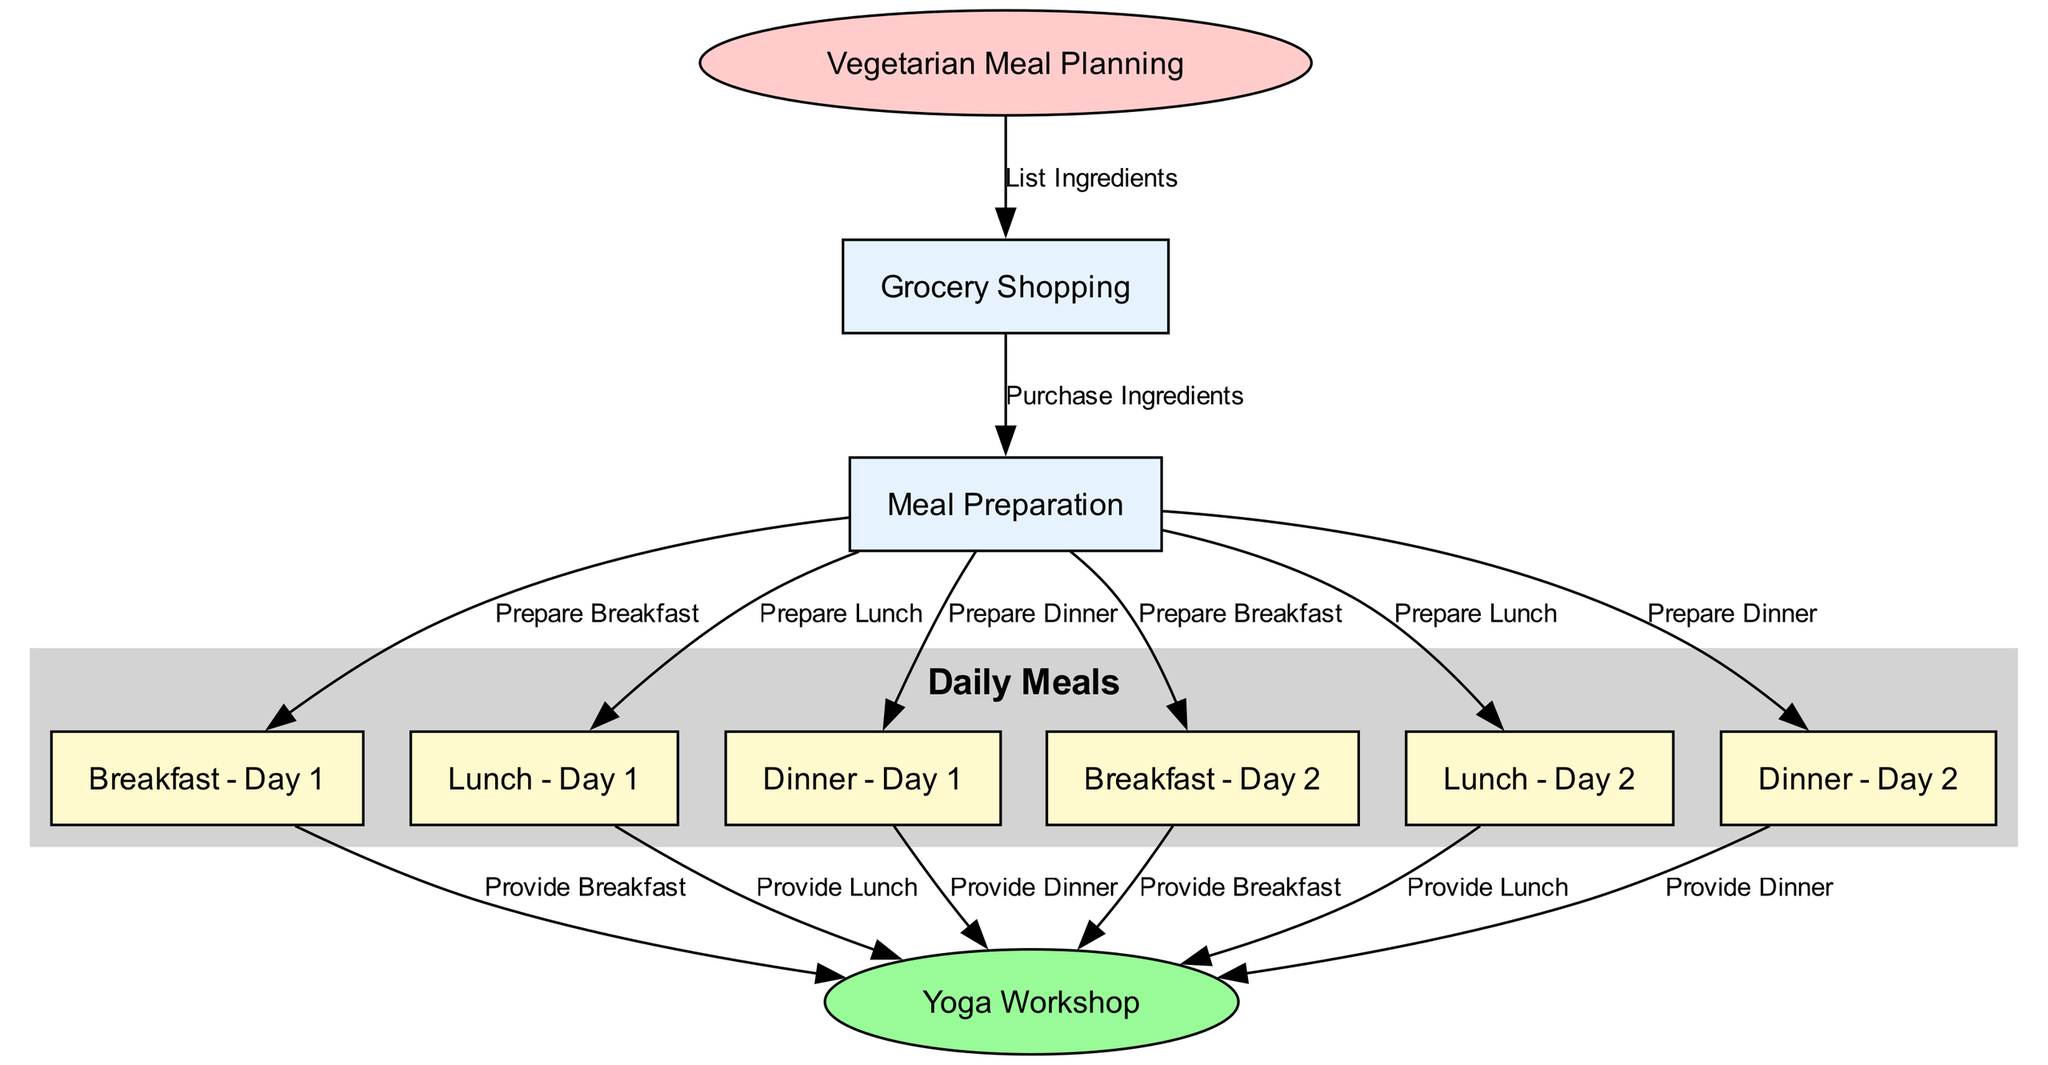What is the starting point of the meal planning chain? The diagram begins with the node labeled "Vegetarian Meal Planning," indicating this is the initial step in the chain.
Answer: Vegetarian Meal Planning How many meals are prepared for Day 1? There are three nodes linked to Day 1: "Breakfast - Day 1," "Lunch - Day 1," and "Dinner - Day 1," indicating three meals are prepared for that day.
Answer: 3 What type of meal is prepared after "mealPrep"? The nodes leading out from "mealPrep" split into "Breakfast - Day 1," "Lunch - Day 1," "Dinner - Day 1," "Breakfast - Day 2," "Lunch - Day 2," and "Dinner - Day 2." Thus, after mealPrep, the type of meal prepared includes breakfast, lunch, and dinner for two days.
Answer: Breakfast, Lunch, Dinner Which day has meals connected directly to the yoga workshop? The nodes "breakfast1," "lunch1," "dinner1," "breakfast2," "lunch2," and "dinner2" all link to "yogaWorkshop." This indicates that meals from both Day 1 and Day 2 are connected to the yoga workshop.
Answer: Day 1 and Day 2 What is the last step of the food chain? The final node in the diagram is "Yoga Workshop," which receives meals from both "Breakfast - Day 1," "Lunch - Day 1," "Dinner - Day 1," "Breakfast - Day 2," "Lunch - Day 2," and "Dinner - Day 2." Therefore, the last step is providing meals to the yoga workshop.
Answer: Yoga Workshop What process occurs between grocery shopping and meal preparation? The edge labeled "Purchase Ingredients" illustrates that after grocery shopping, the next step is to purchase the ingredients, which then leads to meal preparation.
Answer: Purchase Ingredients How many nodes represent daily meals in total? Each day includes three meals, represented by six nodes ("Breakfast - Day 1," "Lunch - Day 1," "Dinner - Day 1," "Breakfast - Day 2," "Lunch - Day 2," "Dinner - Day 2"); hence, there are six nodes for daily meals.
Answer: 6 What labels describe the edges leading to the yoga workshop? The edges leading to the yoga workshop are labeled "Provide Breakfast," "Provide Lunch," and "Provide Dinner," showing the types of meals provided.
Answer: Provide Breakfast, Provide Lunch, Provide Dinner 